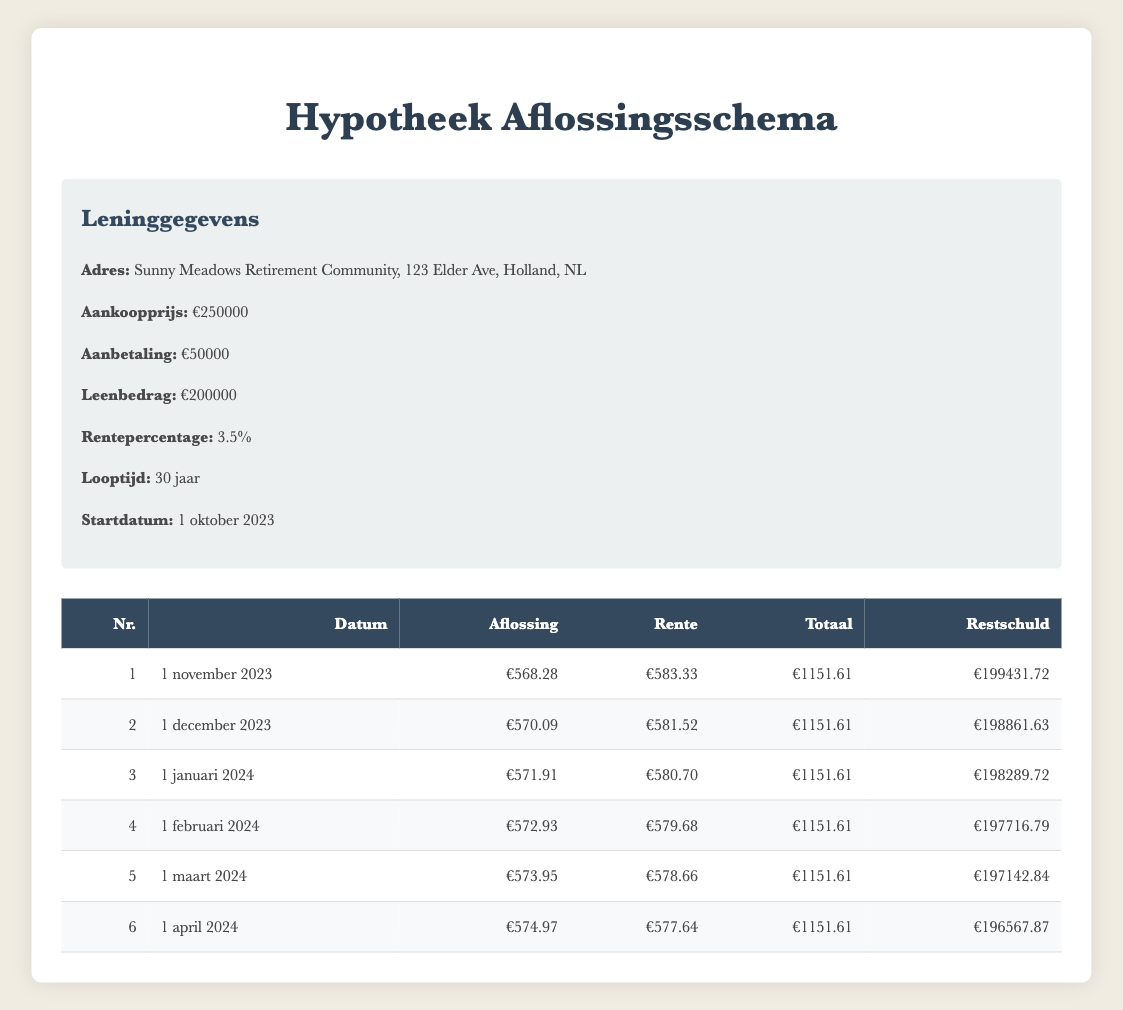What is the total payment for the first month? From the first payment row, the total payment is listed as 1151.61.
Answer: 1151.61 What is the principal payment amount for the second month? The second payment row indicates that the principal payment is 570.09.
Answer: 570.09 Is the interest payment higher for the first month than for the third month? For the first month, the interest payment is 583.33, and for the third month, it is 580.70. Since 583.33 is greater than 580.70, the statement is true.
Answer: Yes What is the remaining balance after the fifth payment? The fifth payment row shows that the remaining balance is 197142.84 after that payment.
Answer: 197142.84 What is the total principal payment made over the first six months? To find the total principal payment, we sum the principal payments for all six months: 568.28 + 570.09 + 571.91 + 572.93 + 573.95 + 574.97 = 3431.13.
Answer: 3431.13 Is the total payment consistent each month? All monthly total payments listed in the table are 1151.61, indicating consistency. Therefore, the answer is true.
Answer: Yes How much interest was paid in the fourth month? The fourth month has an interest payment listed as 579.68.
Answer: 579.68 What is the average principal payment over the first three months? To calculate the average, we first find the sum of the principal payments for the first three months: 568.28 + 570.09 + 571.91 = 1710.28. Then we divide by 3, resulting in an average principal payment of 570.09.
Answer: 570.09 If the interest payments decrease by 1.00 each month, what would be the interest payment for the sixth month? The interest payment for the sixth month is calculated from the fifth month: it is initially 577.64. If it decreased by 1.00, the sixth month’s interest payment would be 577.64 - 1.00 = 576.64.
Answer: 576.64 